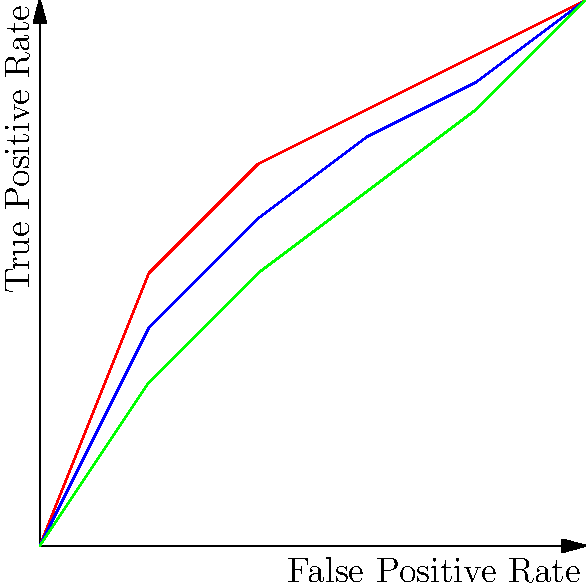Based on the ROC curves shown in the graph, which model demonstrates the best overall performance for binary classification? Explain your reasoning considering the trade-off between true positive rate and false positive rate. To determine the best performing model, we need to analyze the ROC (Receiver Operating Characteristic) curves for each model. The ROC curve plots the True Positive Rate (TPR) against the False Positive Rate (FPR) at various classification thresholds. Here's a step-by-step analysis:

1. Curve position: The closer the ROC curve is to the top-left corner of the plot, the better the model's performance. This indicates a higher true positive rate and a lower false positive rate.

2. Area Under the Curve (AUC): Although not explicitly calculated here, the AUC is represented by the area beneath each curve. A larger AUC indicates better overall performance.

3. Comparing the curves:
   - Model A (red) is consistently above the other curves, indicating it has the highest true positive rate for any given false positive rate.
   - Model B (blue) is the second-best performer, as its curve is mostly above Model C but below Model A.
   - Model C (green) has the lowest curve, suggesting the poorest performance among the three.

4. Trade-off analysis: Model A provides the best trade-off between TPR and FPR, as it achieves higher true positive rates at lower false positive rates compared to the other models.

5. Random classifier: All models perform better than the random classifier (represented by the diagonal dashed line), but Model A shows the greatest improvement.

Based on this analysis, Model A demonstrates the best overall performance for binary classification. It consistently outperforms the other models across different classification thresholds, offering the best balance between identifying true positives and minimizing false positives.
Answer: Model A, as it has the highest ROC curve, indicating the best trade-off between true positive rate and false positive rate. 